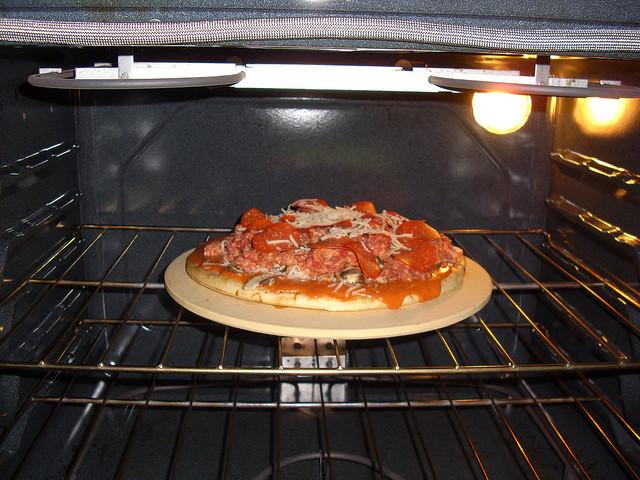What is the pizza being cooked on?
Keep it brief. Pizza stone. Does the food look done?
Concise answer only. No. Is there meat on is pizza?
Short answer required. Yes. Is the oven light on?
Quick response, please. Yes. 